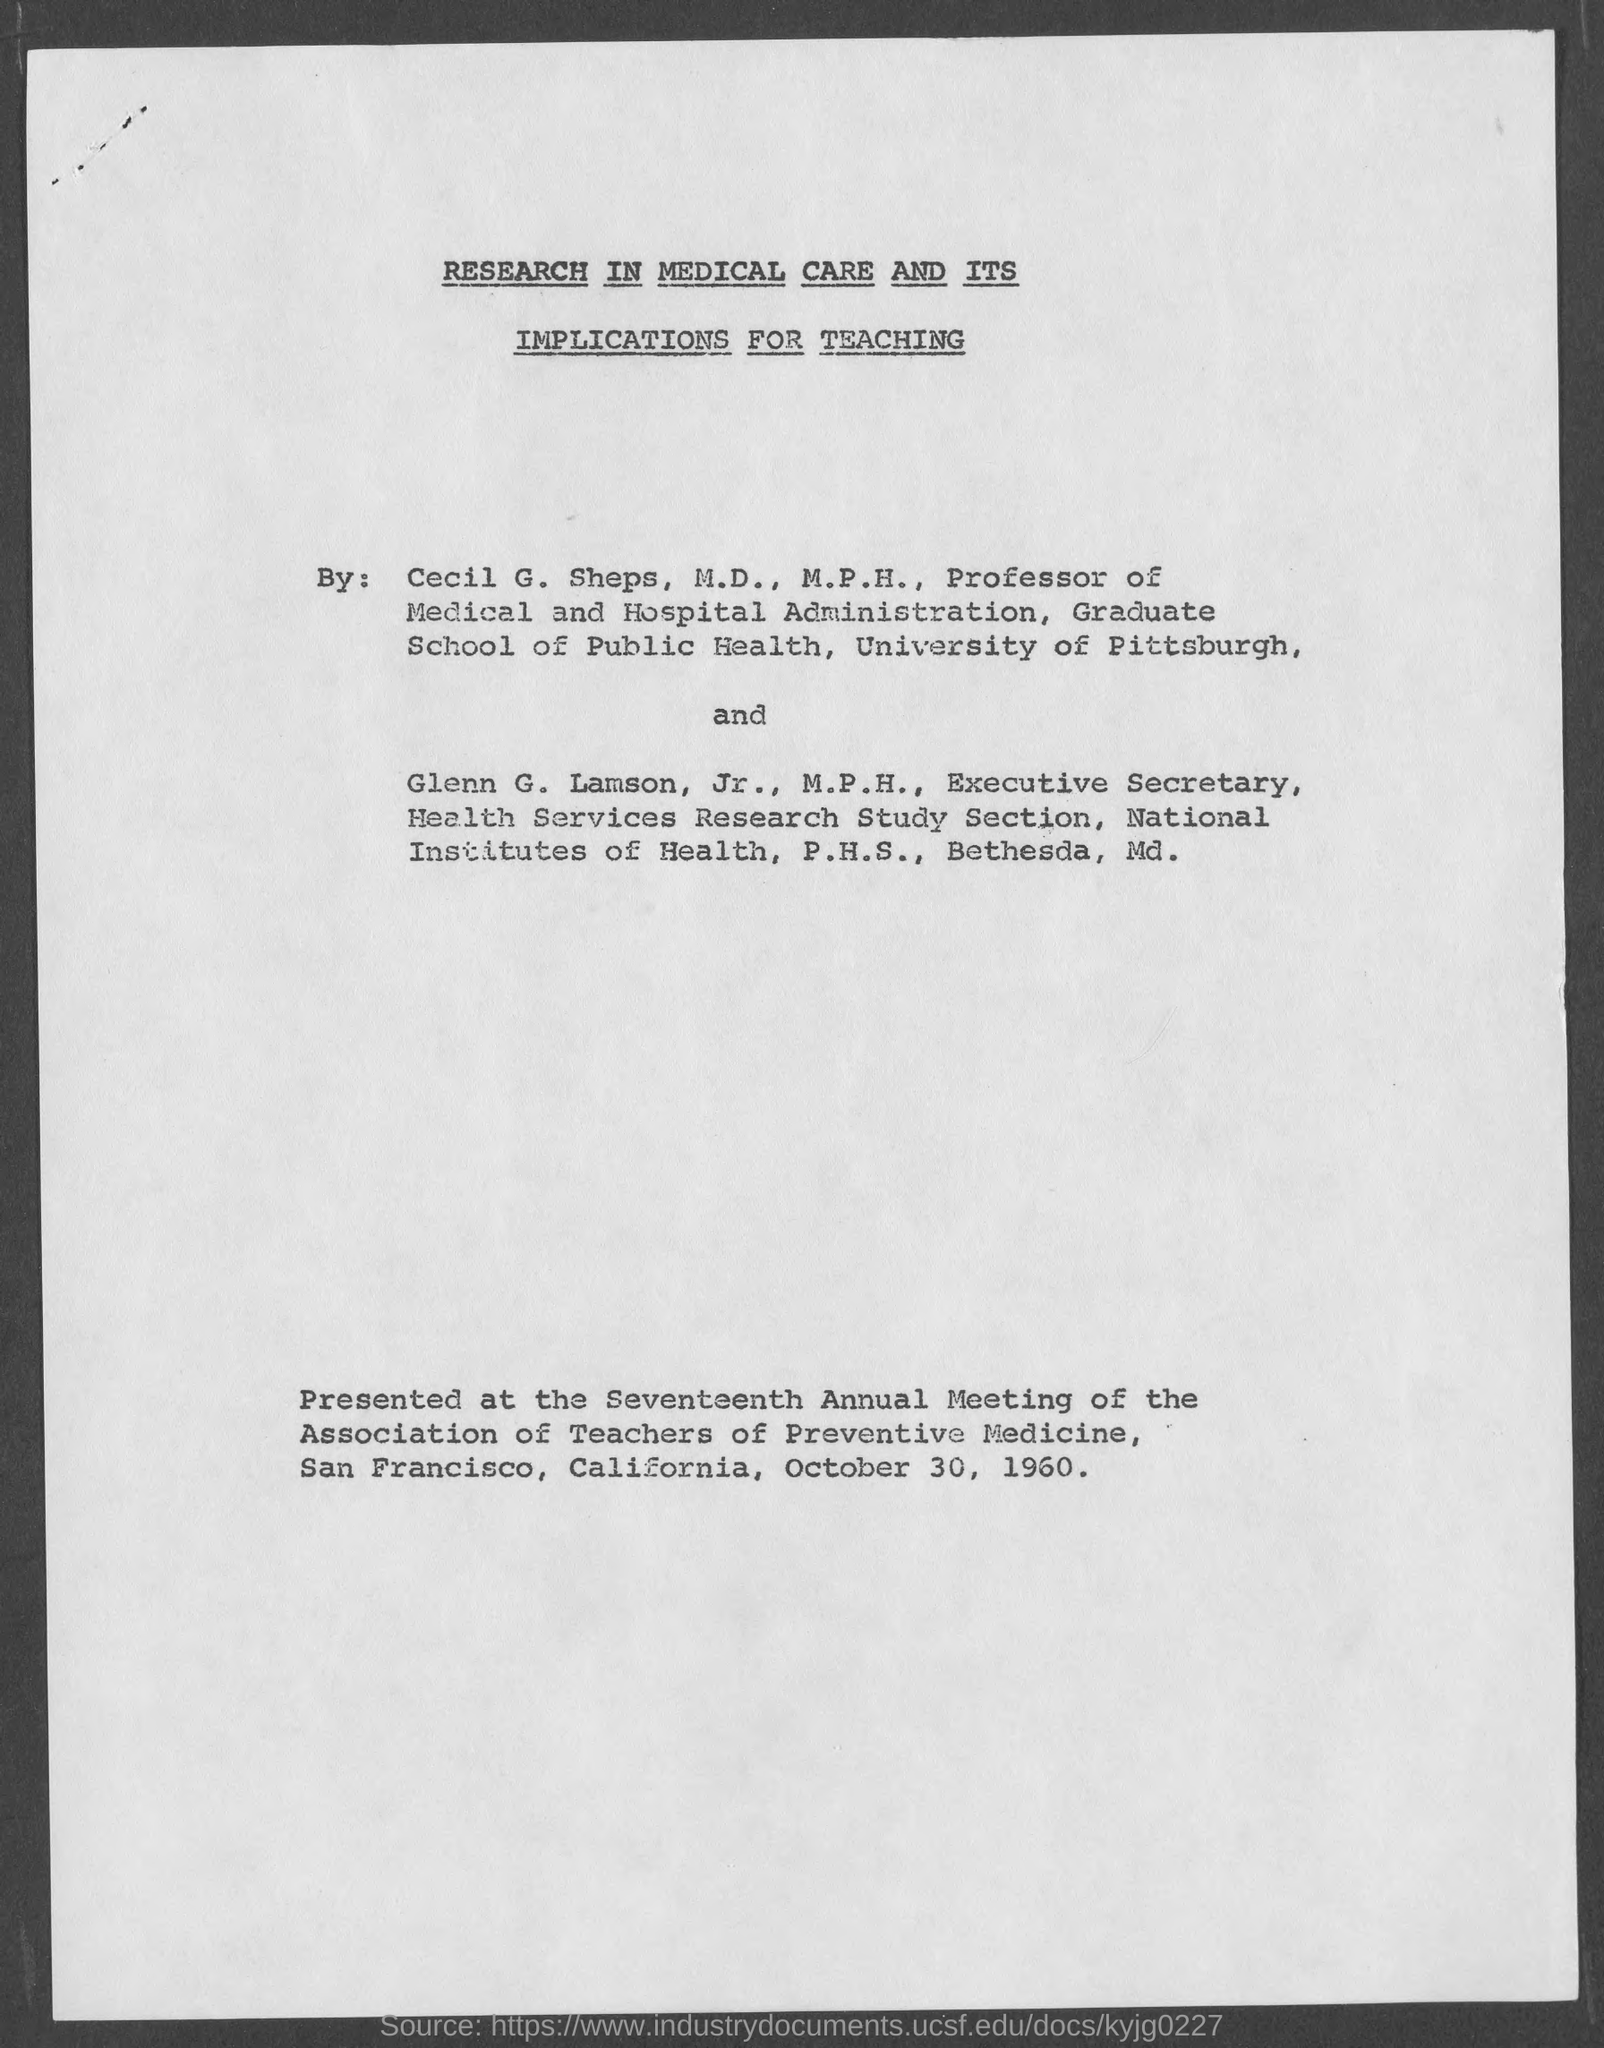Which paper was presented  at the Seventeenth Annual Meeting of the Association of Teachers of Preventive Medicine?
 research in medical care and its implications for teaching 